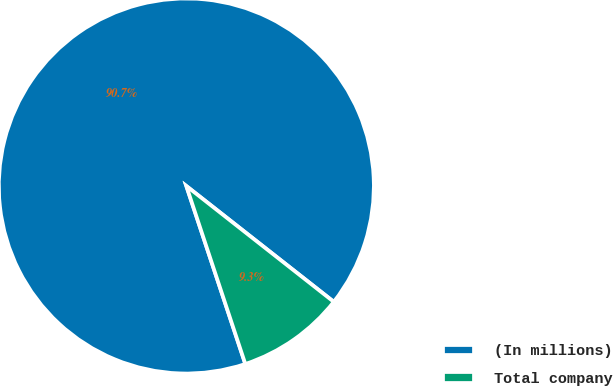Convert chart to OTSL. <chart><loc_0><loc_0><loc_500><loc_500><pie_chart><fcel>(In millions)<fcel>Total company<nl><fcel>90.69%<fcel>9.31%<nl></chart> 